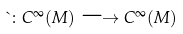Convert formula to latex. <formula><loc_0><loc_0><loc_500><loc_500>\theta \colon C ^ { \infty } ( M ) \longrightarrow C ^ { \infty } ( M )</formula> 